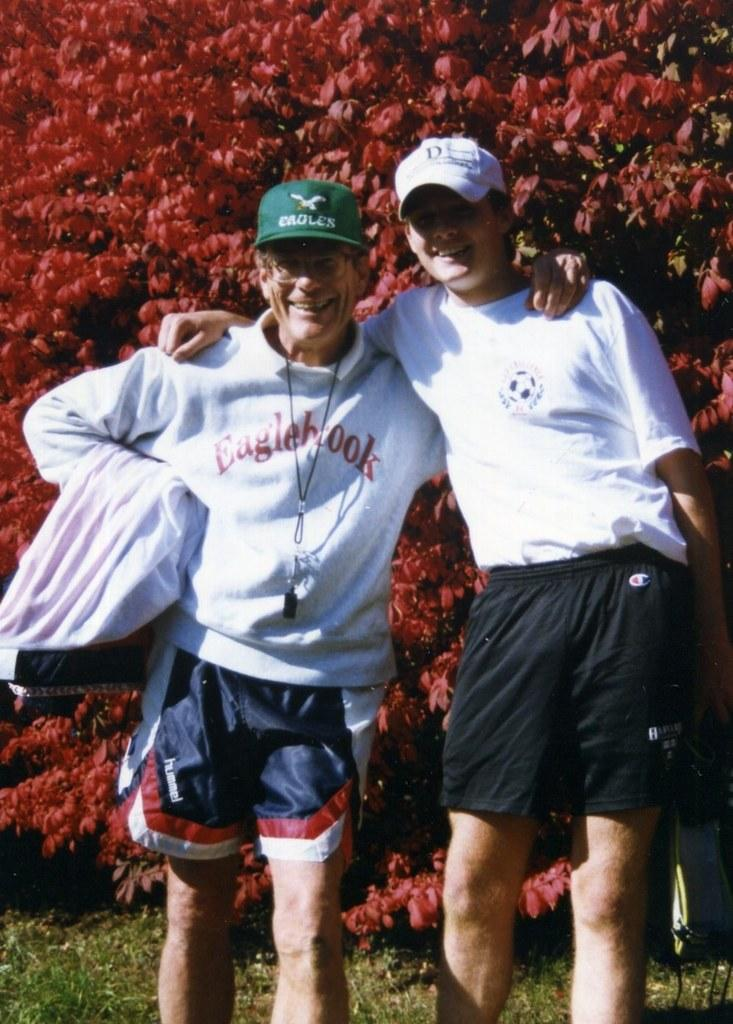How many people are in the image? There are two persons in the image. What are the persons wearing? Both persons are wearing dresses. Can you describe any additional accessories worn by one of the persons? One person is wearing a green cap and spectacles. Where are the persons standing? The persons are standing on the ground. What can be seen in the background of the image? There is a tree visible in the background of the image. What type of toe is visible on the persons in the image? There are no visible toes in the image, as both persons are wearing dresses that cover their feet. --- Facts: 1. There is a car in the image. 2. The car is parked on the street. 3. There are buildings in the background of the image. 4. The sky is visible in the image. 5. The car has a red color. Absurd Topics: parrot, sand, ocean Conversation: What is the main subject of the image? The main subject of the image is a car. Where is the car located in the image? The car is parked on the street. What can be seen in the background of the image? There are buildings in the background of the image. What is visible at the top of the image? The sky is visible in the image. What color is the car? The car has a red color. Reasoning: Let's think step by step in order to produce the conversation. We start by identifying the main subject of the image, which is the car. Then, we describe the location of the car in the image, which is parked on the street. Next, we mention the background of the image, which includes buildings. We then describe the sky visible at the top of the image. Finally, we identify the color of the car, which is red. Absurd Question/Answer: Can you tell me how many parrots are sitting on the car in the image? There are no parrots present in the image; it features a red car parked on the street with buildings in the background and the sky visible at the top. --- Facts: 1. There is a person holding a book in the image. 2. The person is sitting on a chair. 3. There is a table in front of the person. 4. The table has a lamp on it. 5. The background of the image is dark. Absurd Topics: elephant, snow, mountain Conversation: What is the person in the image doing? The person is holding a book in the image. Where is the person sitting? The person is sitting on a chair. What is in front of the person? There is a table in front of the person. What is on the table? The table has a lamp on it. 